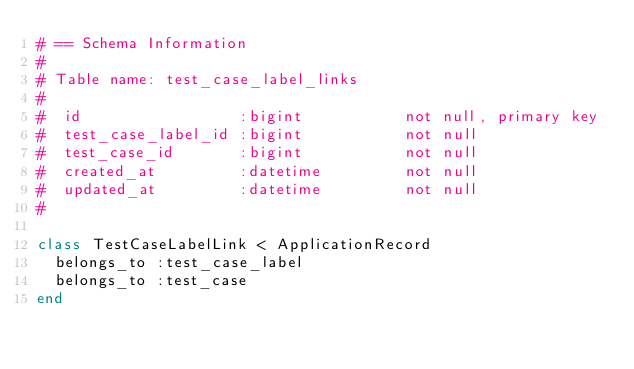Convert code to text. <code><loc_0><loc_0><loc_500><loc_500><_Ruby_># == Schema Information
#
# Table name: test_case_label_links
#
#  id                 :bigint           not null, primary key
#  test_case_label_id :bigint           not null
#  test_case_id       :bigint           not null
#  created_at         :datetime         not null
#  updated_at         :datetime         not null
#

class TestCaseLabelLink < ApplicationRecord
  belongs_to :test_case_label
  belongs_to :test_case
end
</code> 